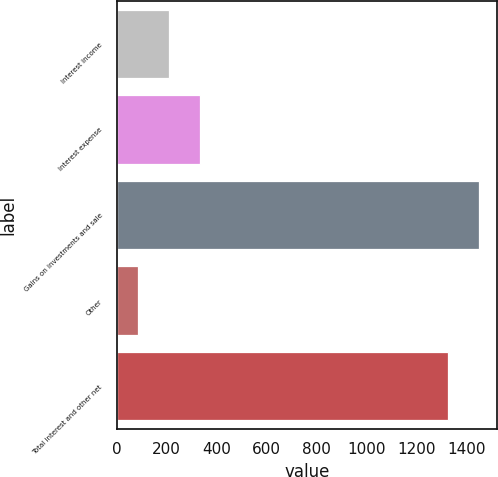<chart> <loc_0><loc_0><loc_500><loc_500><bar_chart><fcel>Interest income<fcel>Interest expense<fcel>Gains on investments and sale<fcel>Other<fcel>Total interest and other net<nl><fcel>209<fcel>335<fcel>1452<fcel>83<fcel>1326<nl></chart> 